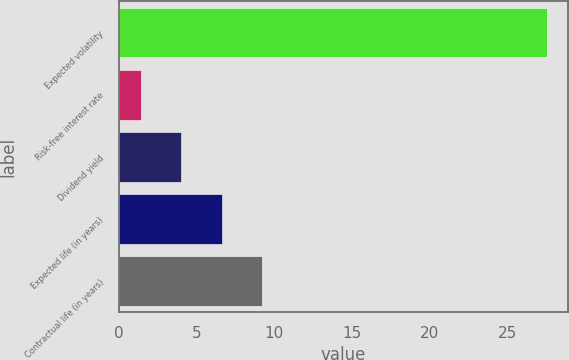<chart> <loc_0><loc_0><loc_500><loc_500><bar_chart><fcel>Expected volatility<fcel>Risk-free interest rate<fcel>Dividend yield<fcel>Expected life (in years)<fcel>Contractual life (in years)<nl><fcel>27.5<fcel>1.4<fcel>4.01<fcel>6.62<fcel>9.23<nl></chart> 